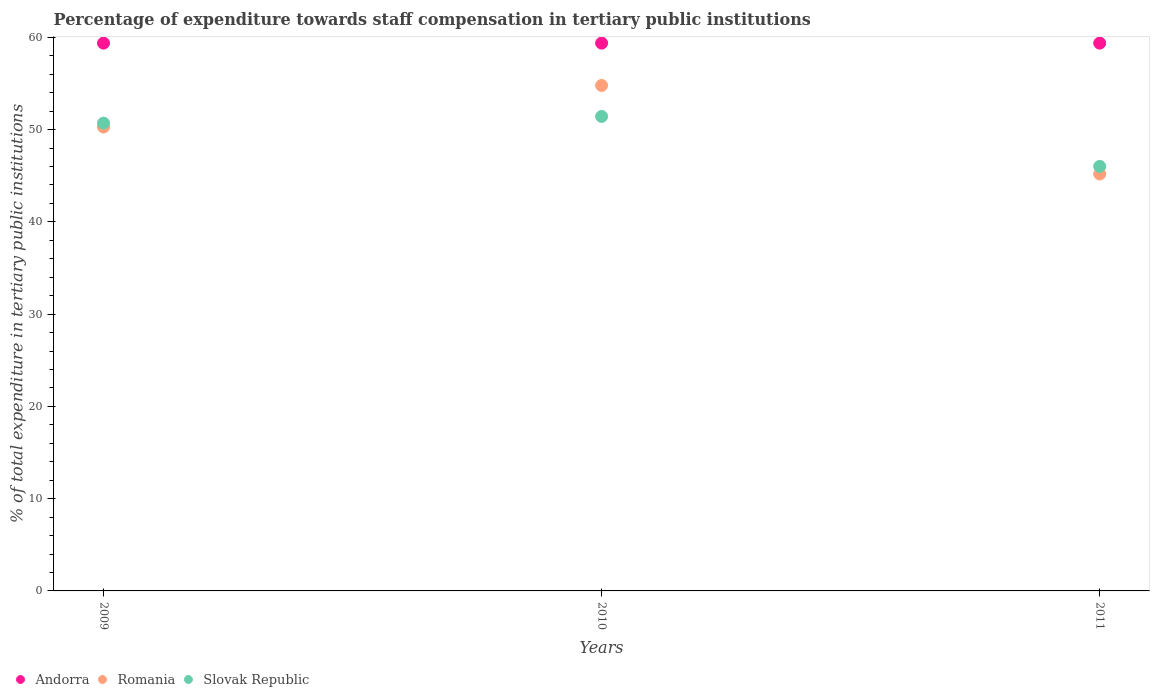How many different coloured dotlines are there?
Provide a succinct answer. 3. Is the number of dotlines equal to the number of legend labels?
Offer a terse response. Yes. What is the percentage of expenditure towards staff compensation in Romania in 2011?
Make the answer very short. 45.19. Across all years, what is the maximum percentage of expenditure towards staff compensation in Andorra?
Keep it short and to the point. 59.38. Across all years, what is the minimum percentage of expenditure towards staff compensation in Slovak Republic?
Offer a terse response. 46.01. In which year was the percentage of expenditure towards staff compensation in Andorra maximum?
Your answer should be very brief. 2009. What is the total percentage of expenditure towards staff compensation in Andorra in the graph?
Keep it short and to the point. 178.13. What is the difference between the percentage of expenditure towards staff compensation in Slovak Republic in 2009 and that in 2011?
Offer a very short reply. 4.69. What is the difference between the percentage of expenditure towards staff compensation in Slovak Republic in 2009 and the percentage of expenditure towards staff compensation in Romania in 2010?
Your answer should be very brief. -4.08. What is the average percentage of expenditure towards staff compensation in Romania per year?
Provide a short and direct response. 50.09. In the year 2009, what is the difference between the percentage of expenditure towards staff compensation in Andorra and percentage of expenditure towards staff compensation in Romania?
Your response must be concise. 9.09. In how many years, is the percentage of expenditure towards staff compensation in Andorra greater than 24 %?
Provide a short and direct response. 3. What is the ratio of the percentage of expenditure towards staff compensation in Slovak Republic in 2010 to that in 2011?
Your answer should be very brief. 1.12. What is the difference between the highest and the second highest percentage of expenditure towards staff compensation in Slovak Republic?
Keep it short and to the point. 0.73. What is the difference between the highest and the lowest percentage of expenditure towards staff compensation in Romania?
Provide a short and direct response. 9.6. In how many years, is the percentage of expenditure towards staff compensation in Romania greater than the average percentage of expenditure towards staff compensation in Romania taken over all years?
Keep it short and to the point. 2. Is the sum of the percentage of expenditure towards staff compensation in Romania in 2009 and 2011 greater than the maximum percentage of expenditure towards staff compensation in Slovak Republic across all years?
Ensure brevity in your answer.  Yes. Does the percentage of expenditure towards staff compensation in Andorra monotonically increase over the years?
Offer a terse response. No. Is the percentage of expenditure towards staff compensation in Andorra strictly less than the percentage of expenditure towards staff compensation in Slovak Republic over the years?
Your response must be concise. No. How many years are there in the graph?
Provide a succinct answer. 3. What is the difference between two consecutive major ticks on the Y-axis?
Your answer should be compact. 10. Are the values on the major ticks of Y-axis written in scientific E-notation?
Keep it short and to the point. No. Does the graph contain grids?
Offer a terse response. No. Where does the legend appear in the graph?
Provide a short and direct response. Bottom left. How are the legend labels stacked?
Your response must be concise. Horizontal. What is the title of the graph?
Offer a terse response. Percentage of expenditure towards staff compensation in tertiary public institutions. Does "Kenya" appear as one of the legend labels in the graph?
Make the answer very short. No. What is the label or title of the X-axis?
Ensure brevity in your answer.  Years. What is the label or title of the Y-axis?
Ensure brevity in your answer.  % of total expenditure in tertiary public institutions. What is the % of total expenditure in tertiary public institutions of Andorra in 2009?
Your response must be concise. 59.38. What is the % of total expenditure in tertiary public institutions in Romania in 2009?
Provide a short and direct response. 50.29. What is the % of total expenditure in tertiary public institutions in Slovak Republic in 2009?
Your answer should be compact. 50.71. What is the % of total expenditure in tertiary public institutions in Andorra in 2010?
Provide a succinct answer. 59.38. What is the % of total expenditure in tertiary public institutions of Romania in 2010?
Your answer should be compact. 54.79. What is the % of total expenditure in tertiary public institutions in Slovak Republic in 2010?
Your answer should be compact. 51.43. What is the % of total expenditure in tertiary public institutions of Andorra in 2011?
Your answer should be compact. 59.38. What is the % of total expenditure in tertiary public institutions of Romania in 2011?
Provide a succinct answer. 45.19. What is the % of total expenditure in tertiary public institutions in Slovak Republic in 2011?
Offer a very short reply. 46.01. Across all years, what is the maximum % of total expenditure in tertiary public institutions of Andorra?
Keep it short and to the point. 59.38. Across all years, what is the maximum % of total expenditure in tertiary public institutions in Romania?
Your response must be concise. 54.79. Across all years, what is the maximum % of total expenditure in tertiary public institutions of Slovak Republic?
Your answer should be very brief. 51.43. Across all years, what is the minimum % of total expenditure in tertiary public institutions of Andorra?
Keep it short and to the point. 59.38. Across all years, what is the minimum % of total expenditure in tertiary public institutions of Romania?
Offer a very short reply. 45.19. Across all years, what is the minimum % of total expenditure in tertiary public institutions of Slovak Republic?
Your answer should be very brief. 46.01. What is the total % of total expenditure in tertiary public institutions of Andorra in the graph?
Your answer should be very brief. 178.13. What is the total % of total expenditure in tertiary public institutions of Romania in the graph?
Provide a short and direct response. 150.27. What is the total % of total expenditure in tertiary public institutions of Slovak Republic in the graph?
Offer a very short reply. 148.15. What is the difference between the % of total expenditure in tertiary public institutions of Andorra in 2009 and that in 2010?
Give a very brief answer. 0. What is the difference between the % of total expenditure in tertiary public institutions in Romania in 2009 and that in 2010?
Provide a short and direct response. -4.5. What is the difference between the % of total expenditure in tertiary public institutions in Slovak Republic in 2009 and that in 2010?
Offer a terse response. -0.73. What is the difference between the % of total expenditure in tertiary public institutions of Romania in 2009 and that in 2011?
Keep it short and to the point. 5.09. What is the difference between the % of total expenditure in tertiary public institutions in Slovak Republic in 2009 and that in 2011?
Your answer should be compact. 4.69. What is the difference between the % of total expenditure in tertiary public institutions of Romania in 2010 and that in 2011?
Your response must be concise. 9.6. What is the difference between the % of total expenditure in tertiary public institutions in Slovak Republic in 2010 and that in 2011?
Provide a succinct answer. 5.42. What is the difference between the % of total expenditure in tertiary public institutions in Andorra in 2009 and the % of total expenditure in tertiary public institutions in Romania in 2010?
Provide a succinct answer. 4.59. What is the difference between the % of total expenditure in tertiary public institutions of Andorra in 2009 and the % of total expenditure in tertiary public institutions of Slovak Republic in 2010?
Give a very brief answer. 7.95. What is the difference between the % of total expenditure in tertiary public institutions in Romania in 2009 and the % of total expenditure in tertiary public institutions in Slovak Republic in 2010?
Provide a short and direct response. -1.14. What is the difference between the % of total expenditure in tertiary public institutions in Andorra in 2009 and the % of total expenditure in tertiary public institutions in Romania in 2011?
Offer a terse response. 14.19. What is the difference between the % of total expenditure in tertiary public institutions in Andorra in 2009 and the % of total expenditure in tertiary public institutions in Slovak Republic in 2011?
Offer a terse response. 13.36. What is the difference between the % of total expenditure in tertiary public institutions in Romania in 2009 and the % of total expenditure in tertiary public institutions in Slovak Republic in 2011?
Make the answer very short. 4.27. What is the difference between the % of total expenditure in tertiary public institutions in Andorra in 2010 and the % of total expenditure in tertiary public institutions in Romania in 2011?
Your answer should be compact. 14.19. What is the difference between the % of total expenditure in tertiary public institutions of Andorra in 2010 and the % of total expenditure in tertiary public institutions of Slovak Republic in 2011?
Make the answer very short. 13.36. What is the difference between the % of total expenditure in tertiary public institutions of Romania in 2010 and the % of total expenditure in tertiary public institutions of Slovak Republic in 2011?
Give a very brief answer. 8.77. What is the average % of total expenditure in tertiary public institutions in Andorra per year?
Ensure brevity in your answer.  59.38. What is the average % of total expenditure in tertiary public institutions in Romania per year?
Your answer should be compact. 50.09. What is the average % of total expenditure in tertiary public institutions in Slovak Republic per year?
Provide a succinct answer. 49.38. In the year 2009, what is the difference between the % of total expenditure in tertiary public institutions of Andorra and % of total expenditure in tertiary public institutions of Romania?
Your answer should be compact. 9.09. In the year 2009, what is the difference between the % of total expenditure in tertiary public institutions of Andorra and % of total expenditure in tertiary public institutions of Slovak Republic?
Give a very brief answer. 8.67. In the year 2009, what is the difference between the % of total expenditure in tertiary public institutions of Romania and % of total expenditure in tertiary public institutions of Slovak Republic?
Provide a short and direct response. -0.42. In the year 2010, what is the difference between the % of total expenditure in tertiary public institutions in Andorra and % of total expenditure in tertiary public institutions in Romania?
Your answer should be compact. 4.59. In the year 2010, what is the difference between the % of total expenditure in tertiary public institutions of Andorra and % of total expenditure in tertiary public institutions of Slovak Republic?
Ensure brevity in your answer.  7.95. In the year 2010, what is the difference between the % of total expenditure in tertiary public institutions in Romania and % of total expenditure in tertiary public institutions in Slovak Republic?
Keep it short and to the point. 3.36. In the year 2011, what is the difference between the % of total expenditure in tertiary public institutions in Andorra and % of total expenditure in tertiary public institutions in Romania?
Your answer should be compact. 14.19. In the year 2011, what is the difference between the % of total expenditure in tertiary public institutions of Andorra and % of total expenditure in tertiary public institutions of Slovak Republic?
Your response must be concise. 13.36. In the year 2011, what is the difference between the % of total expenditure in tertiary public institutions in Romania and % of total expenditure in tertiary public institutions in Slovak Republic?
Your response must be concise. -0.82. What is the ratio of the % of total expenditure in tertiary public institutions of Andorra in 2009 to that in 2010?
Provide a short and direct response. 1. What is the ratio of the % of total expenditure in tertiary public institutions in Romania in 2009 to that in 2010?
Your answer should be compact. 0.92. What is the ratio of the % of total expenditure in tertiary public institutions of Slovak Republic in 2009 to that in 2010?
Your response must be concise. 0.99. What is the ratio of the % of total expenditure in tertiary public institutions in Andorra in 2009 to that in 2011?
Ensure brevity in your answer.  1. What is the ratio of the % of total expenditure in tertiary public institutions in Romania in 2009 to that in 2011?
Provide a short and direct response. 1.11. What is the ratio of the % of total expenditure in tertiary public institutions in Slovak Republic in 2009 to that in 2011?
Provide a short and direct response. 1.1. What is the ratio of the % of total expenditure in tertiary public institutions of Andorra in 2010 to that in 2011?
Ensure brevity in your answer.  1. What is the ratio of the % of total expenditure in tertiary public institutions in Romania in 2010 to that in 2011?
Make the answer very short. 1.21. What is the ratio of the % of total expenditure in tertiary public institutions of Slovak Republic in 2010 to that in 2011?
Provide a short and direct response. 1.12. What is the difference between the highest and the second highest % of total expenditure in tertiary public institutions in Andorra?
Make the answer very short. 0. What is the difference between the highest and the second highest % of total expenditure in tertiary public institutions in Romania?
Your answer should be compact. 4.5. What is the difference between the highest and the second highest % of total expenditure in tertiary public institutions of Slovak Republic?
Provide a short and direct response. 0.73. What is the difference between the highest and the lowest % of total expenditure in tertiary public institutions of Andorra?
Your answer should be compact. 0. What is the difference between the highest and the lowest % of total expenditure in tertiary public institutions in Romania?
Offer a very short reply. 9.6. What is the difference between the highest and the lowest % of total expenditure in tertiary public institutions of Slovak Republic?
Provide a succinct answer. 5.42. 